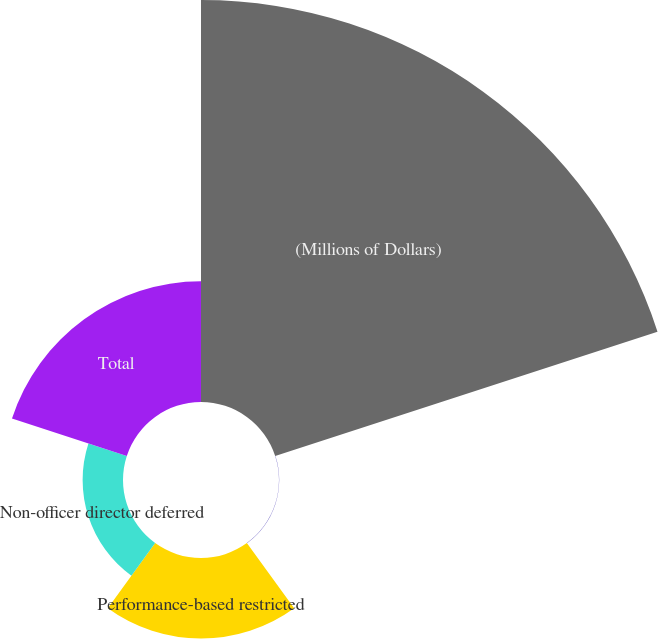Convert chart to OTSL. <chart><loc_0><loc_0><loc_500><loc_500><pie_chart><fcel>(Millions of Dollars)<fcel>Restricted stock units<fcel>Performance-based restricted<fcel>Non-officer director deferred<fcel>Total<nl><fcel>62.43%<fcel>0.03%<fcel>12.51%<fcel>6.27%<fcel>18.75%<nl></chart> 